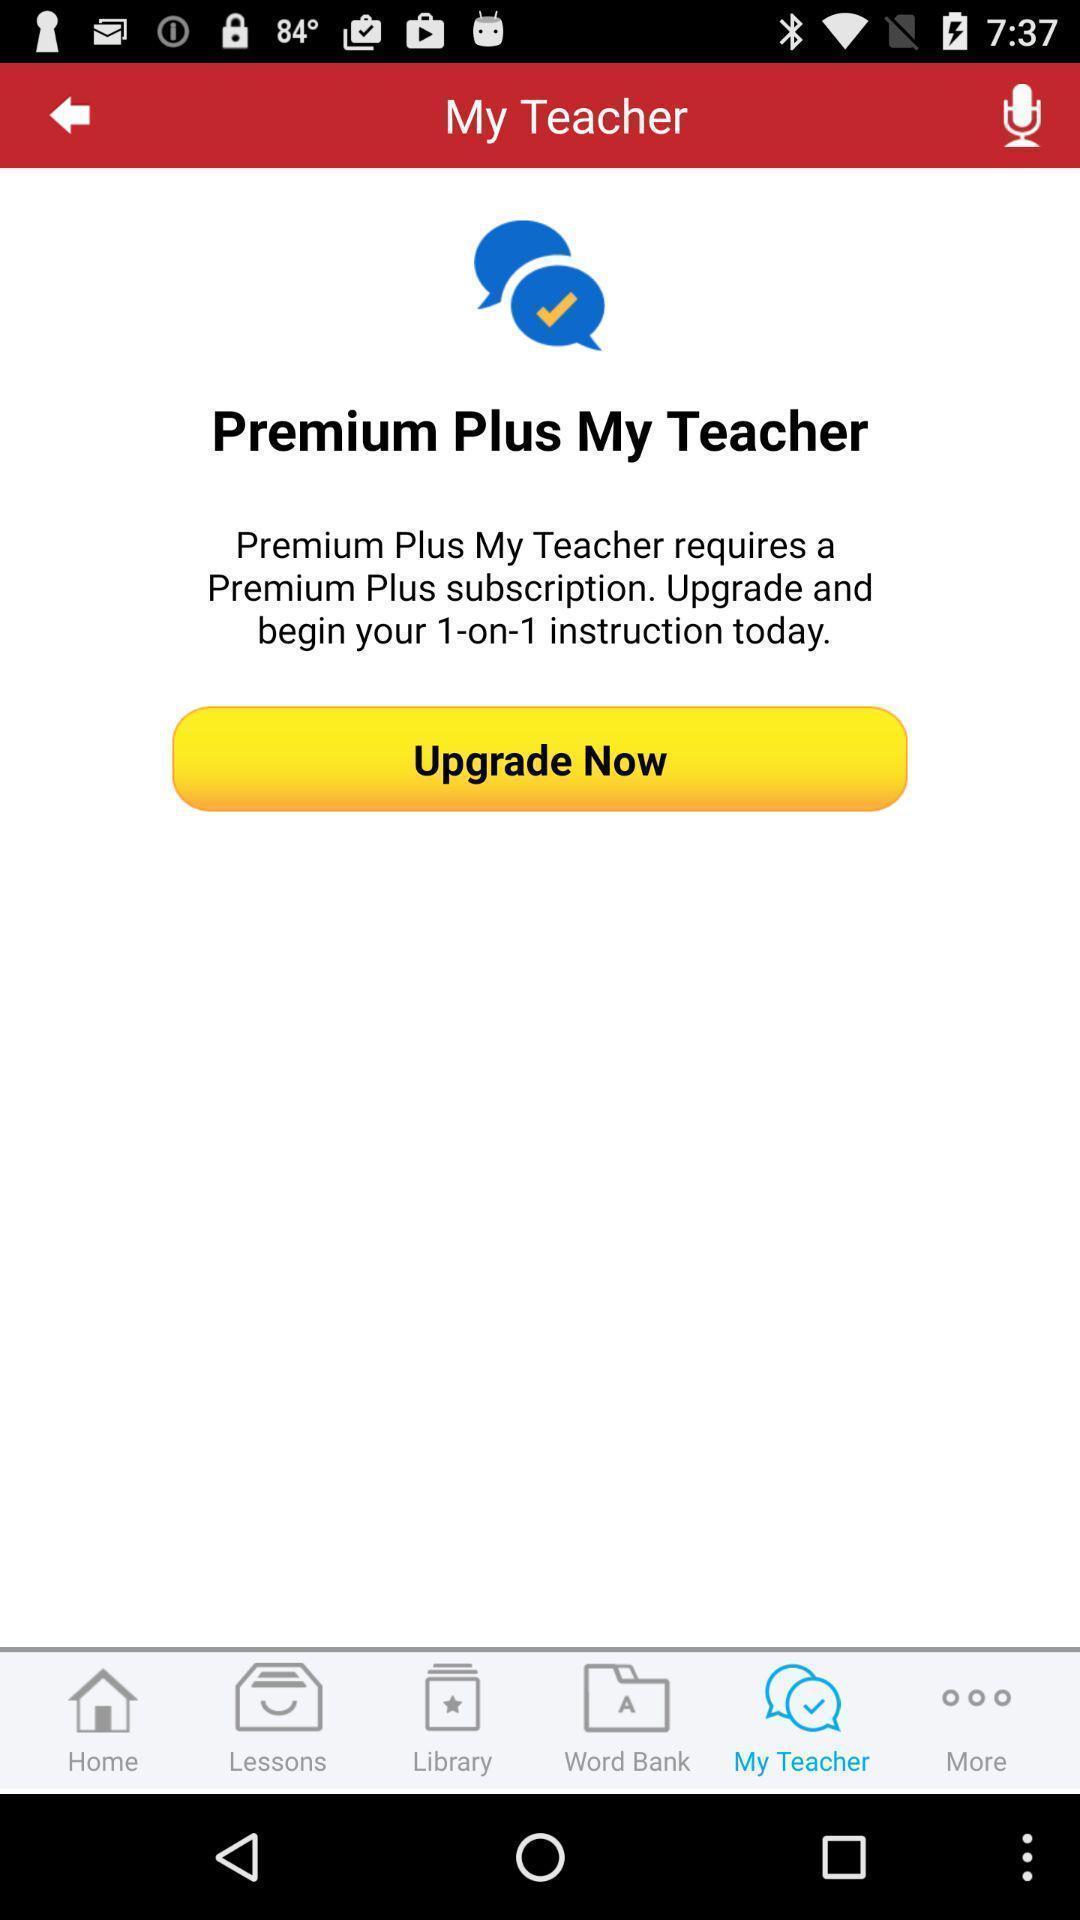Describe the visual elements of this screenshot. Upgrade option is displaying in a learning app. 